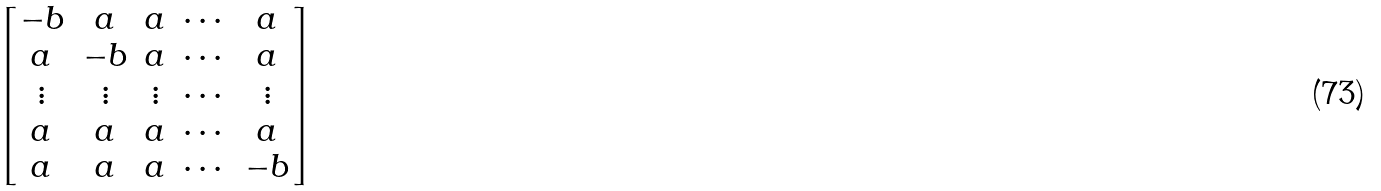Convert formula to latex. <formula><loc_0><loc_0><loc_500><loc_500>\begin{bmatrix} - b & a & a & \cdots & a \\ a & - b & a & \cdots & a \\ \vdots & \vdots & \vdots & \cdots & \vdots \\ a & a & a & \cdots & a \\ a & a & a & \cdots & - b \end{bmatrix}</formula> 